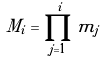<formula> <loc_0><loc_0><loc_500><loc_500>M _ { i } = \prod _ { j = 1 } ^ { i } m _ { j }</formula> 